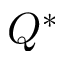Convert formula to latex. <formula><loc_0><loc_0><loc_500><loc_500>Q ^ { * }</formula> 